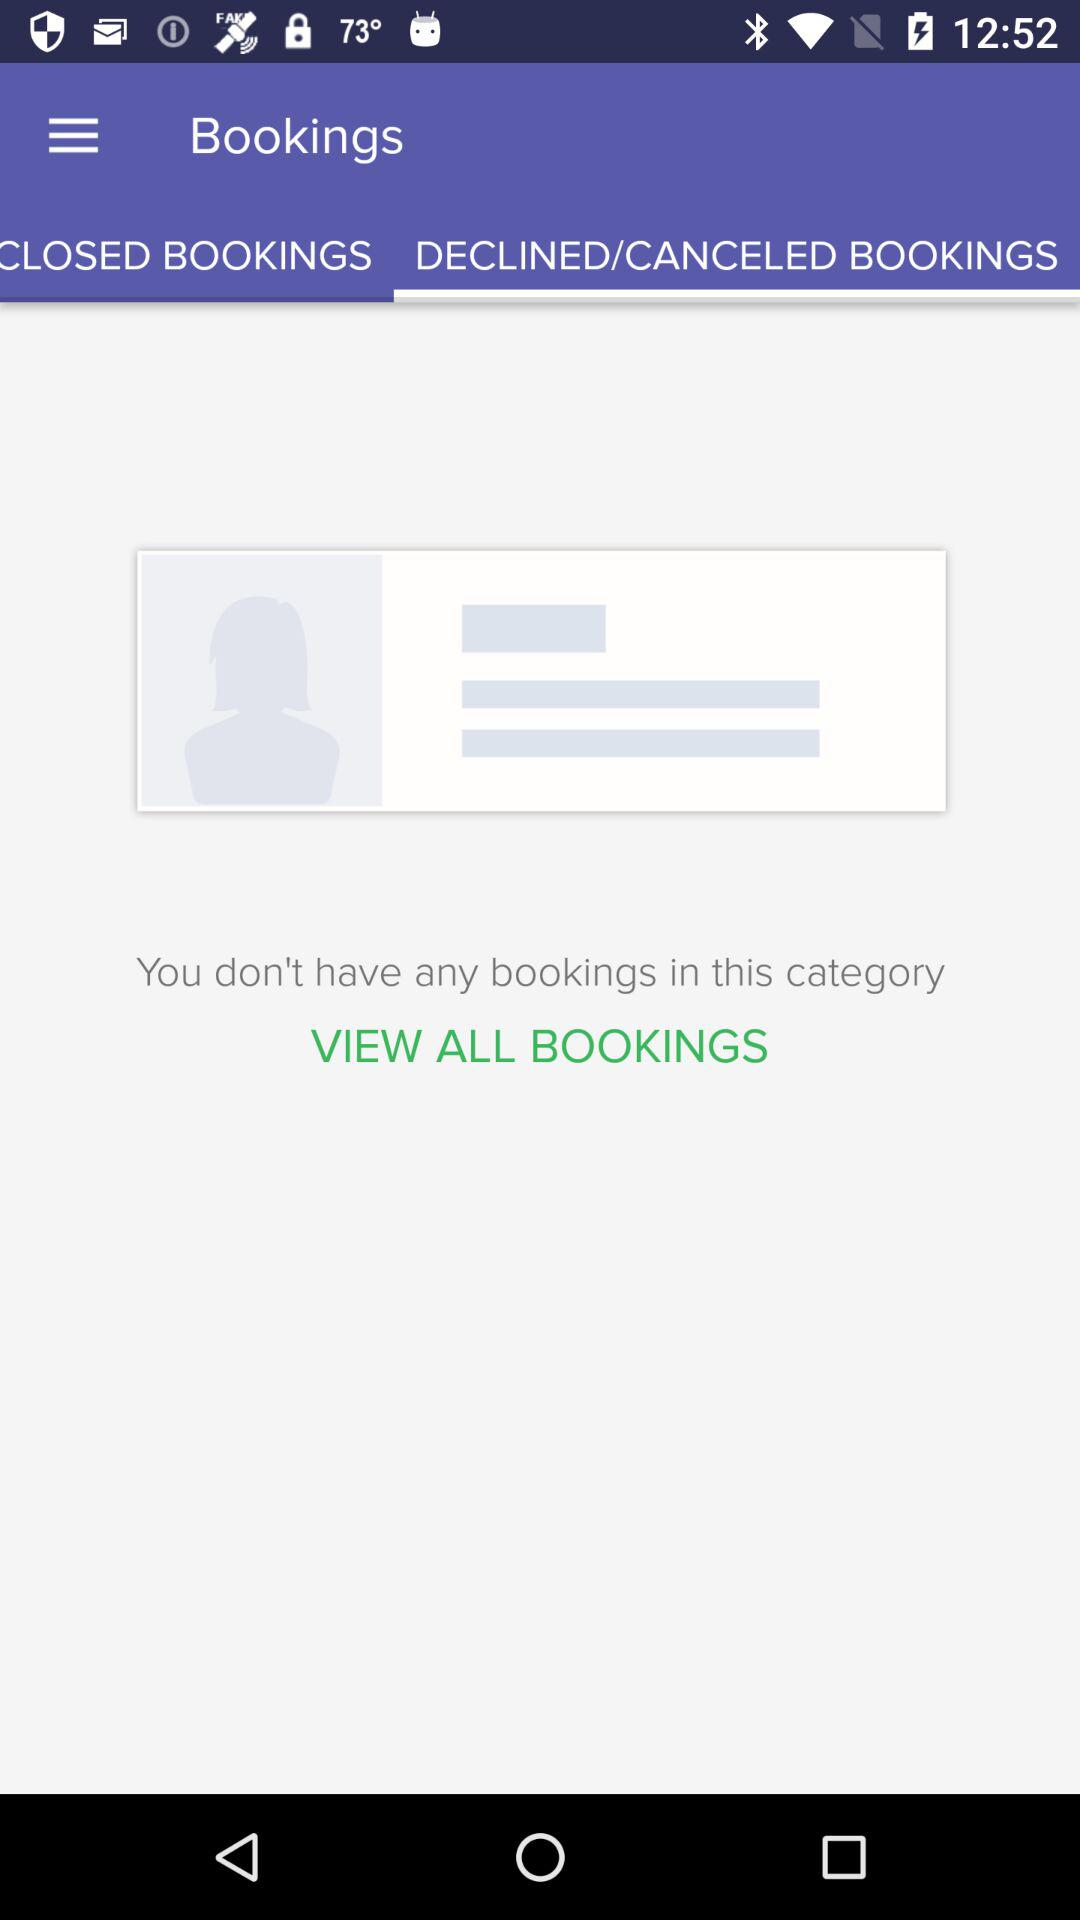Which tab is selected? The selected tab is "DECLINED/CANCELED BOOKINGS". 